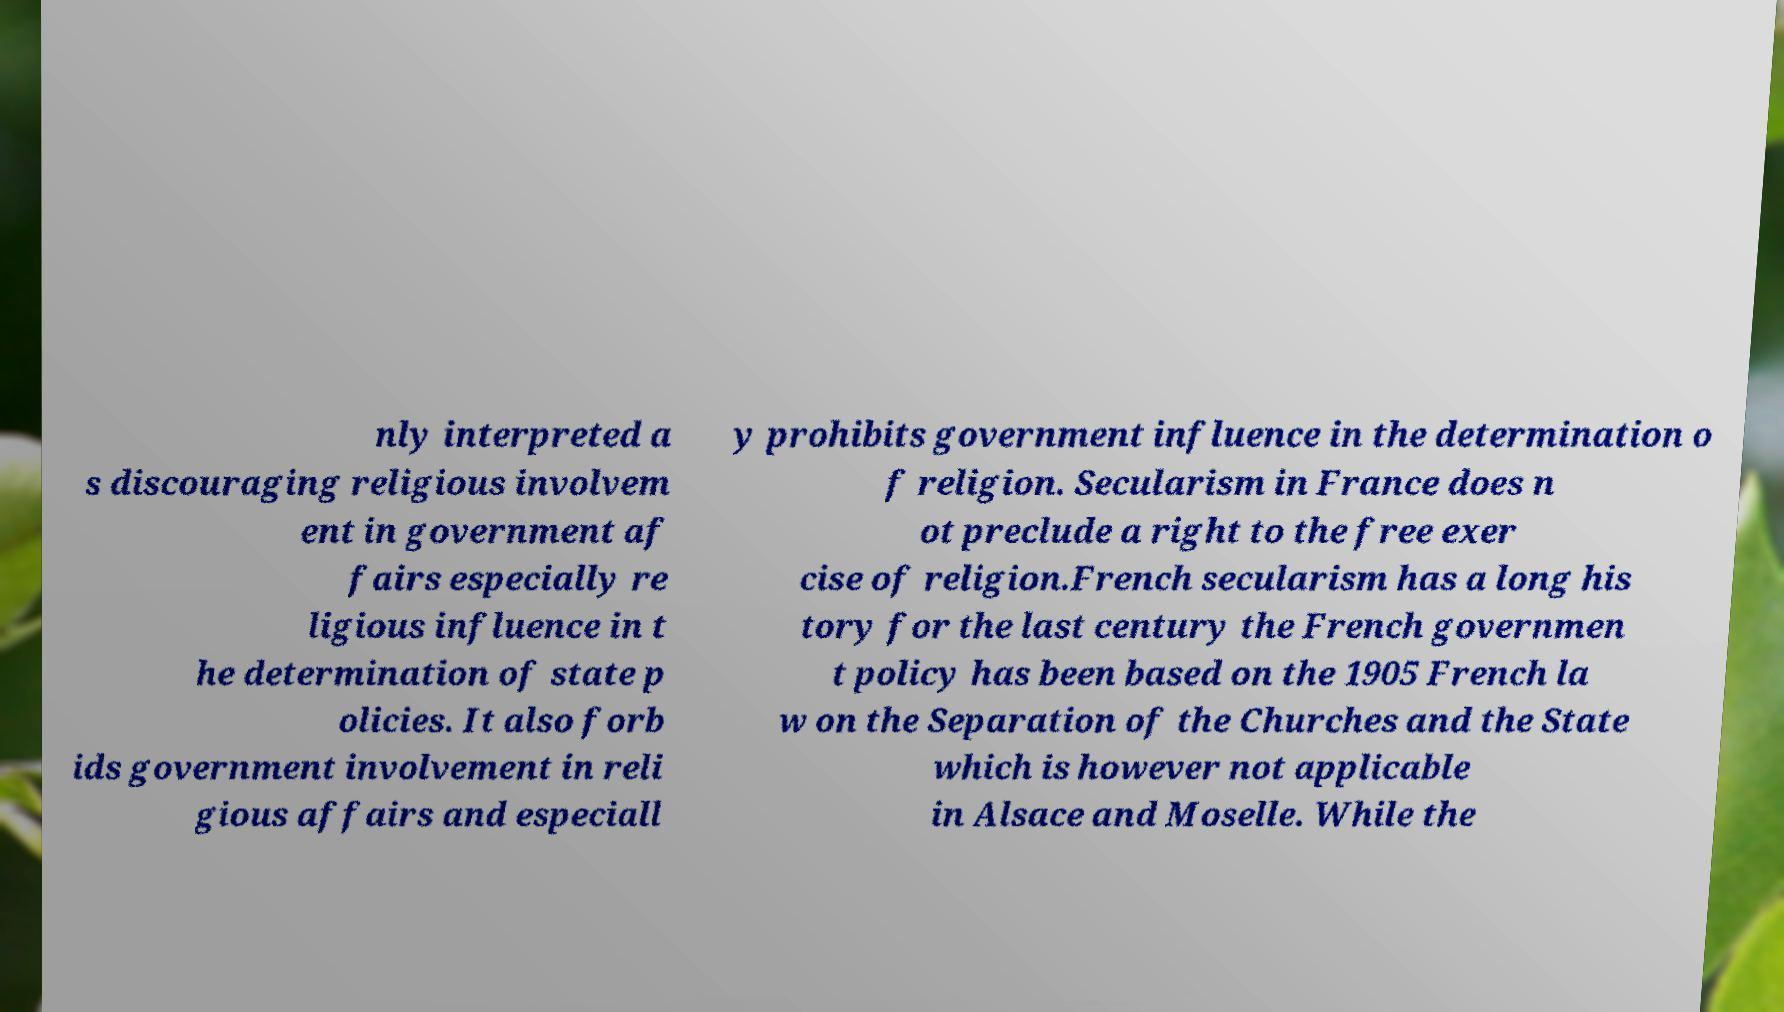What messages or text are displayed in this image? I need them in a readable, typed format. nly interpreted a s discouraging religious involvem ent in government af fairs especially re ligious influence in t he determination of state p olicies. It also forb ids government involvement in reli gious affairs and especiall y prohibits government influence in the determination o f religion. Secularism in France does n ot preclude a right to the free exer cise of religion.French secularism has a long his tory for the last century the French governmen t policy has been based on the 1905 French la w on the Separation of the Churches and the State which is however not applicable in Alsace and Moselle. While the 